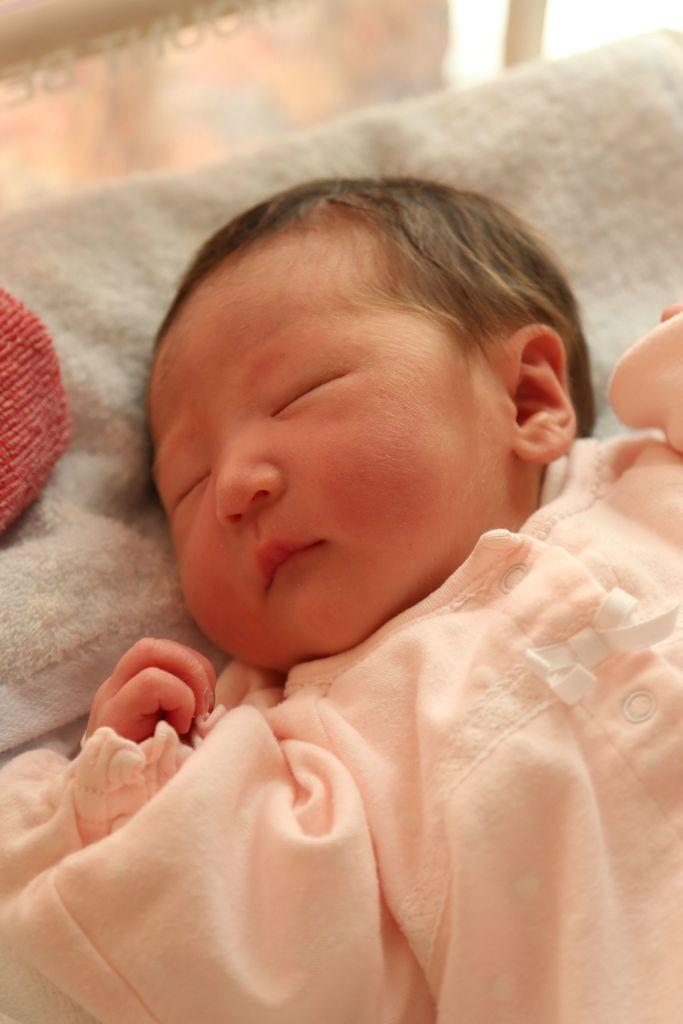What is the main subject of the image? There is a baby lying on a bed in the image. Are there any other objects or items visible in the image? Yes, there are objects in the image. Can you describe the setting of the image? The image may have been taken in a room. How many balls are being juggled by the baby in the image? There are no balls present in the image, and the baby is not shown juggling anything. 